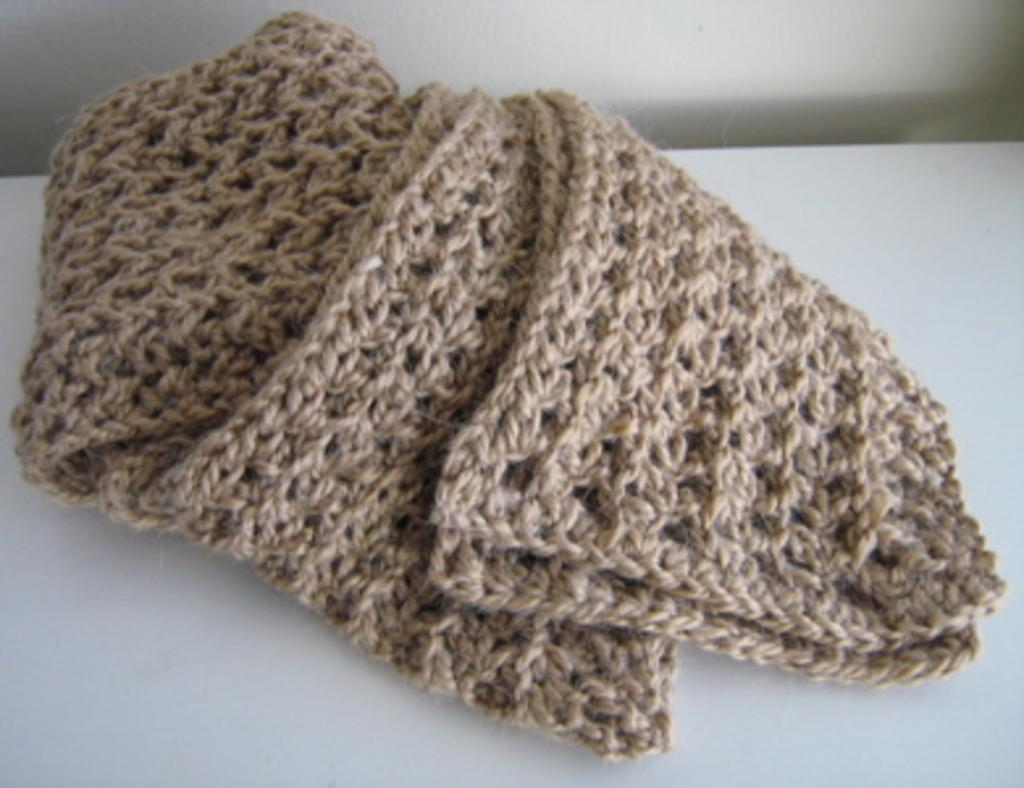What is on the table in the image? There is a crochet on the table. What can be seen behind the table? There is a wall behind the table. How many rings does the yak have on its neck in the image? There is no yak present in the image, so it is not possible to determine how many rings it might have on its neck. 